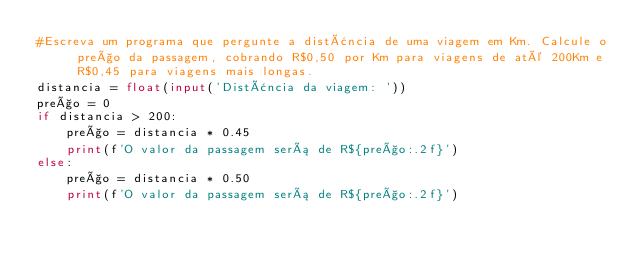<code> <loc_0><loc_0><loc_500><loc_500><_Python_>#Escreva um programa que pergunte a distância de uma viagem em Km. Calcule o preço da passagem, cobrando R$0,50 por Km para viagens de até 200Km e R$0,45 para viagens mais longas.
distancia = float(input('Distância da viagem: '))
preço = 0
if distancia > 200:
    preço = distancia * 0.45
    print(f'O valor da passagem será de R${preço:.2f}')
else:
    preço = distancia * 0.50
    print(f'O valor da passagem será de R${preço:.2f}')
</code> 